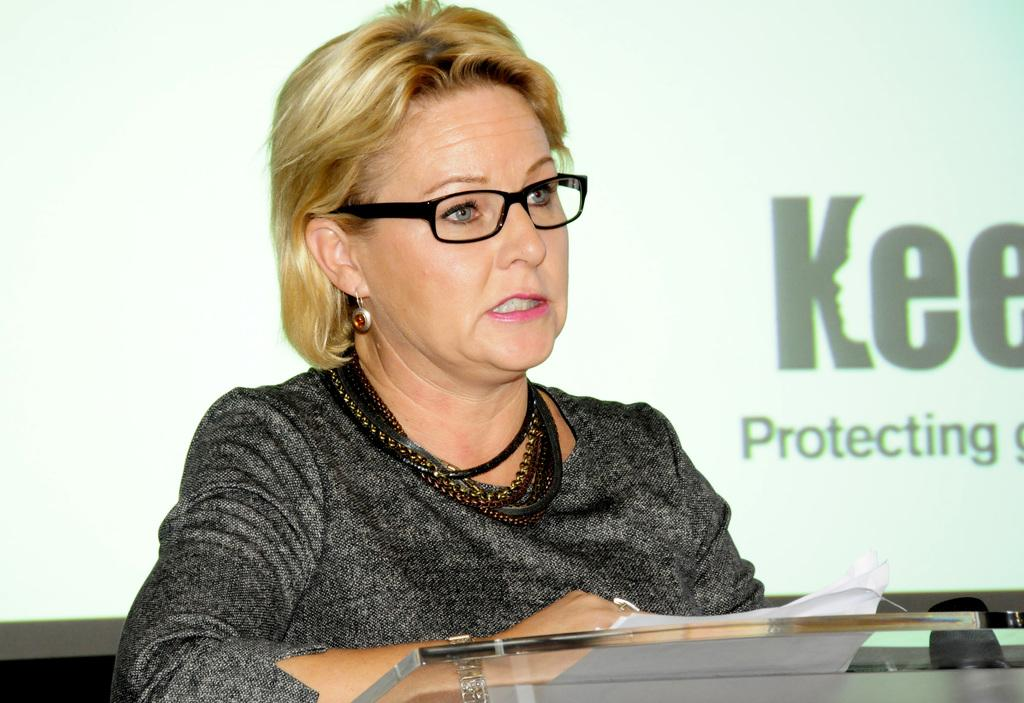Who is the main subject in the image? There is a woman in the image. What is the woman standing in front of? The woman is in front of a glass table. Can you describe the background of the image? There might be a wall in the background of the image, and there is text on the wall. What type of kite is the doctor flying in the image? There is no doctor or kite present in the image. What kind of trouble is the woman experiencing in the image? There is no indication of trouble in the image; the woman is simply standing in front of a glass table. 